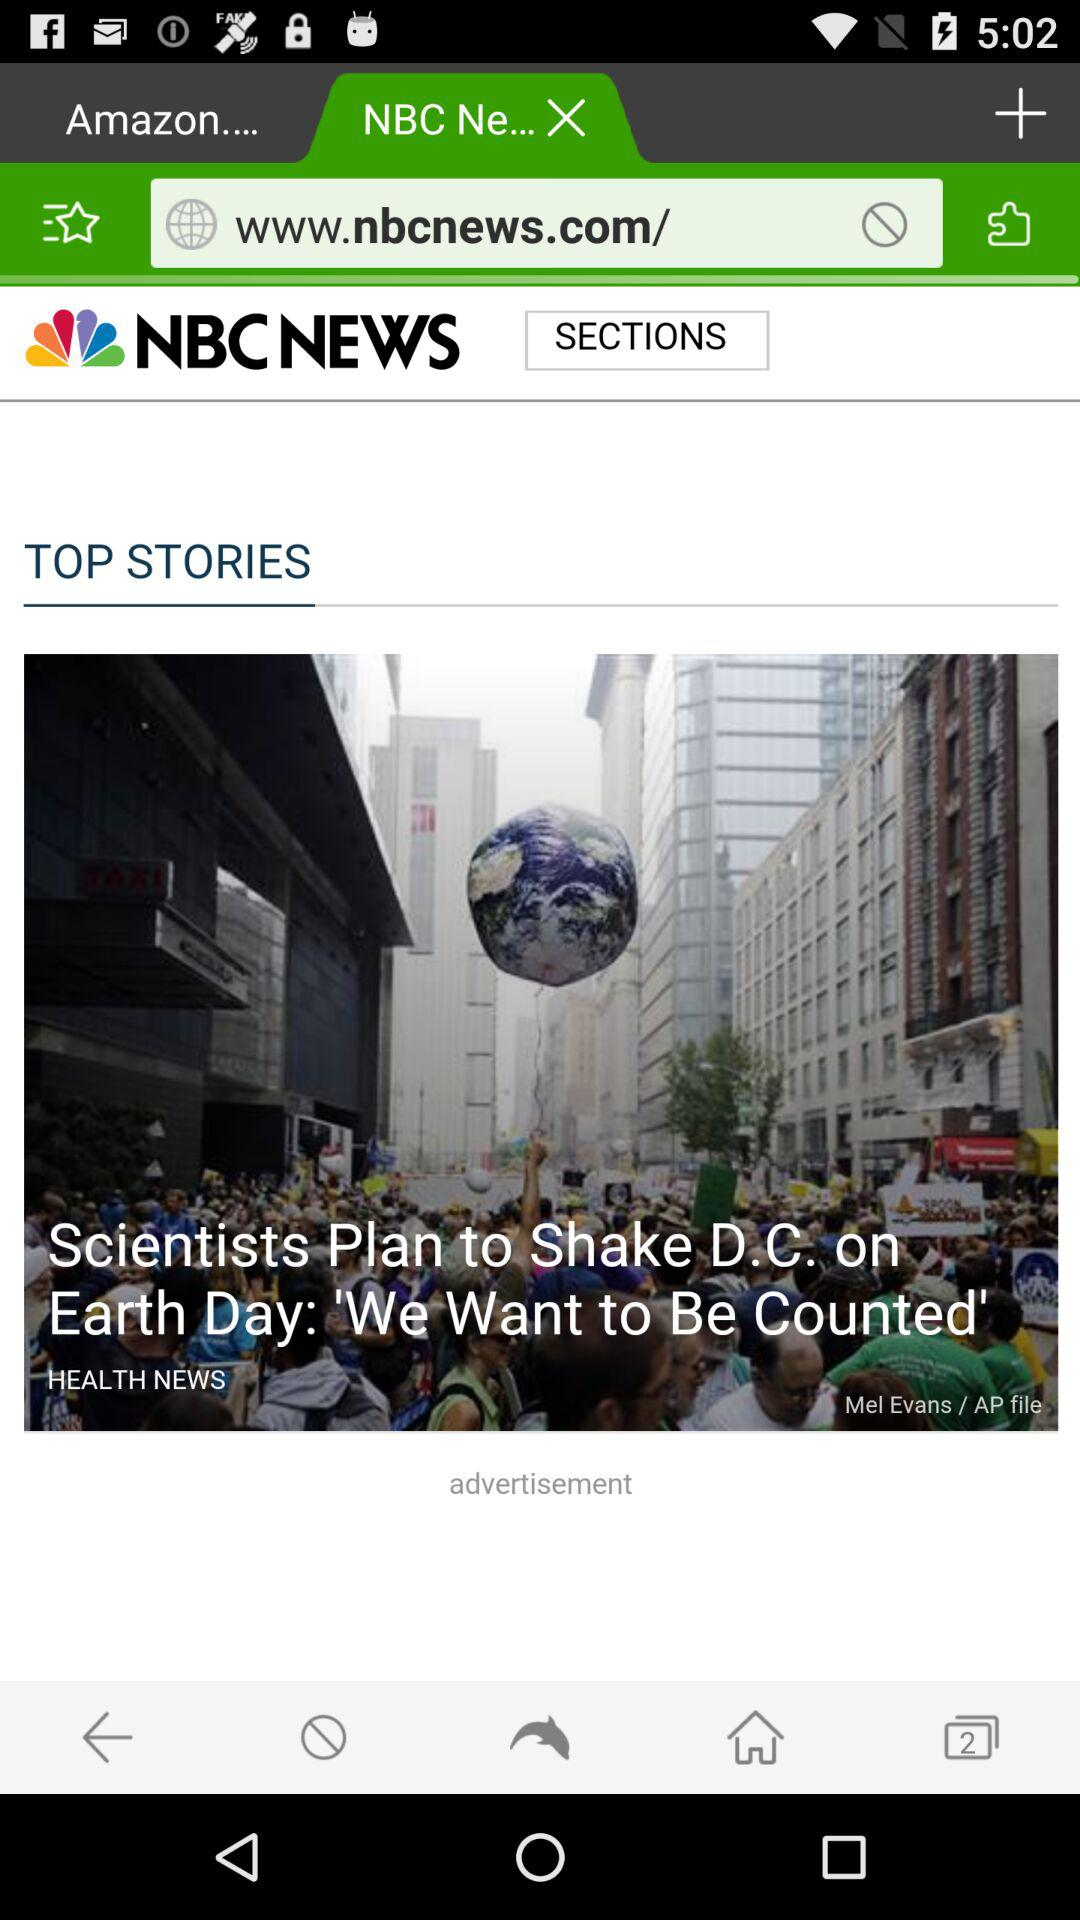What is the headline? The headline is "Scientists Plan to Shake D.C. on Earth Day: 'We Want to Be Counted'". 